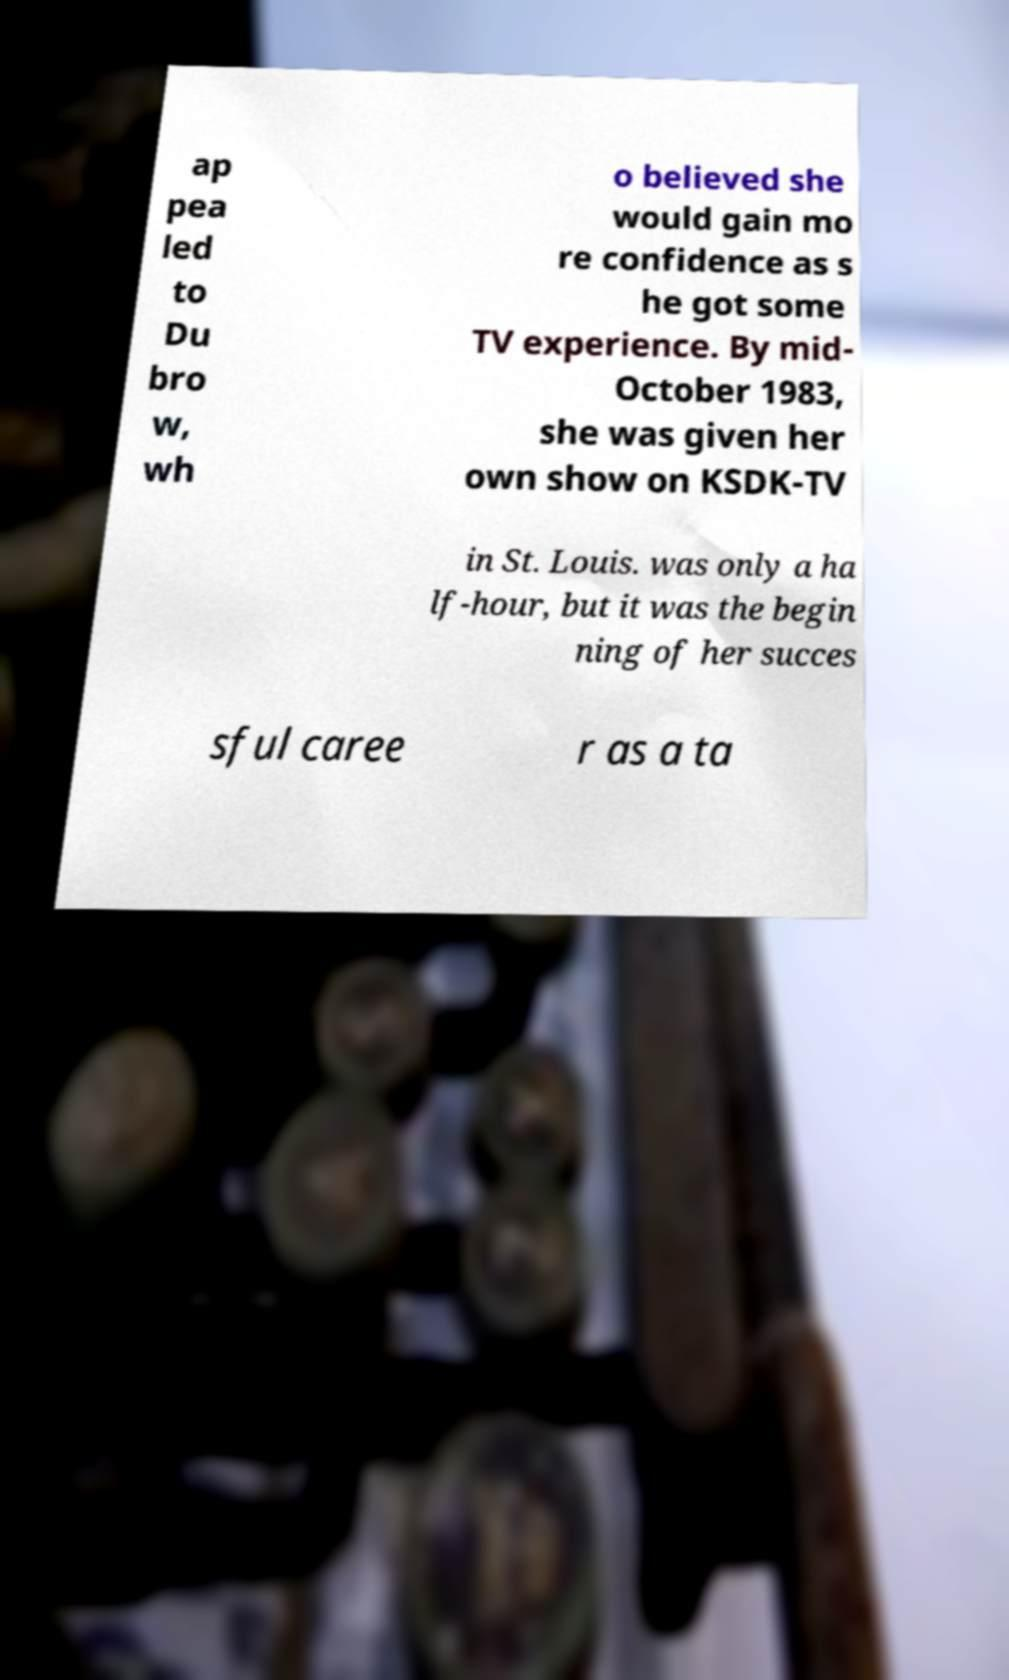Could you assist in decoding the text presented in this image and type it out clearly? ap pea led to Du bro w, wh o believed she would gain mo re confidence as s he got some TV experience. By mid- October 1983, she was given her own show on KSDK-TV in St. Louis. was only a ha lf-hour, but it was the begin ning of her succes sful caree r as a ta 